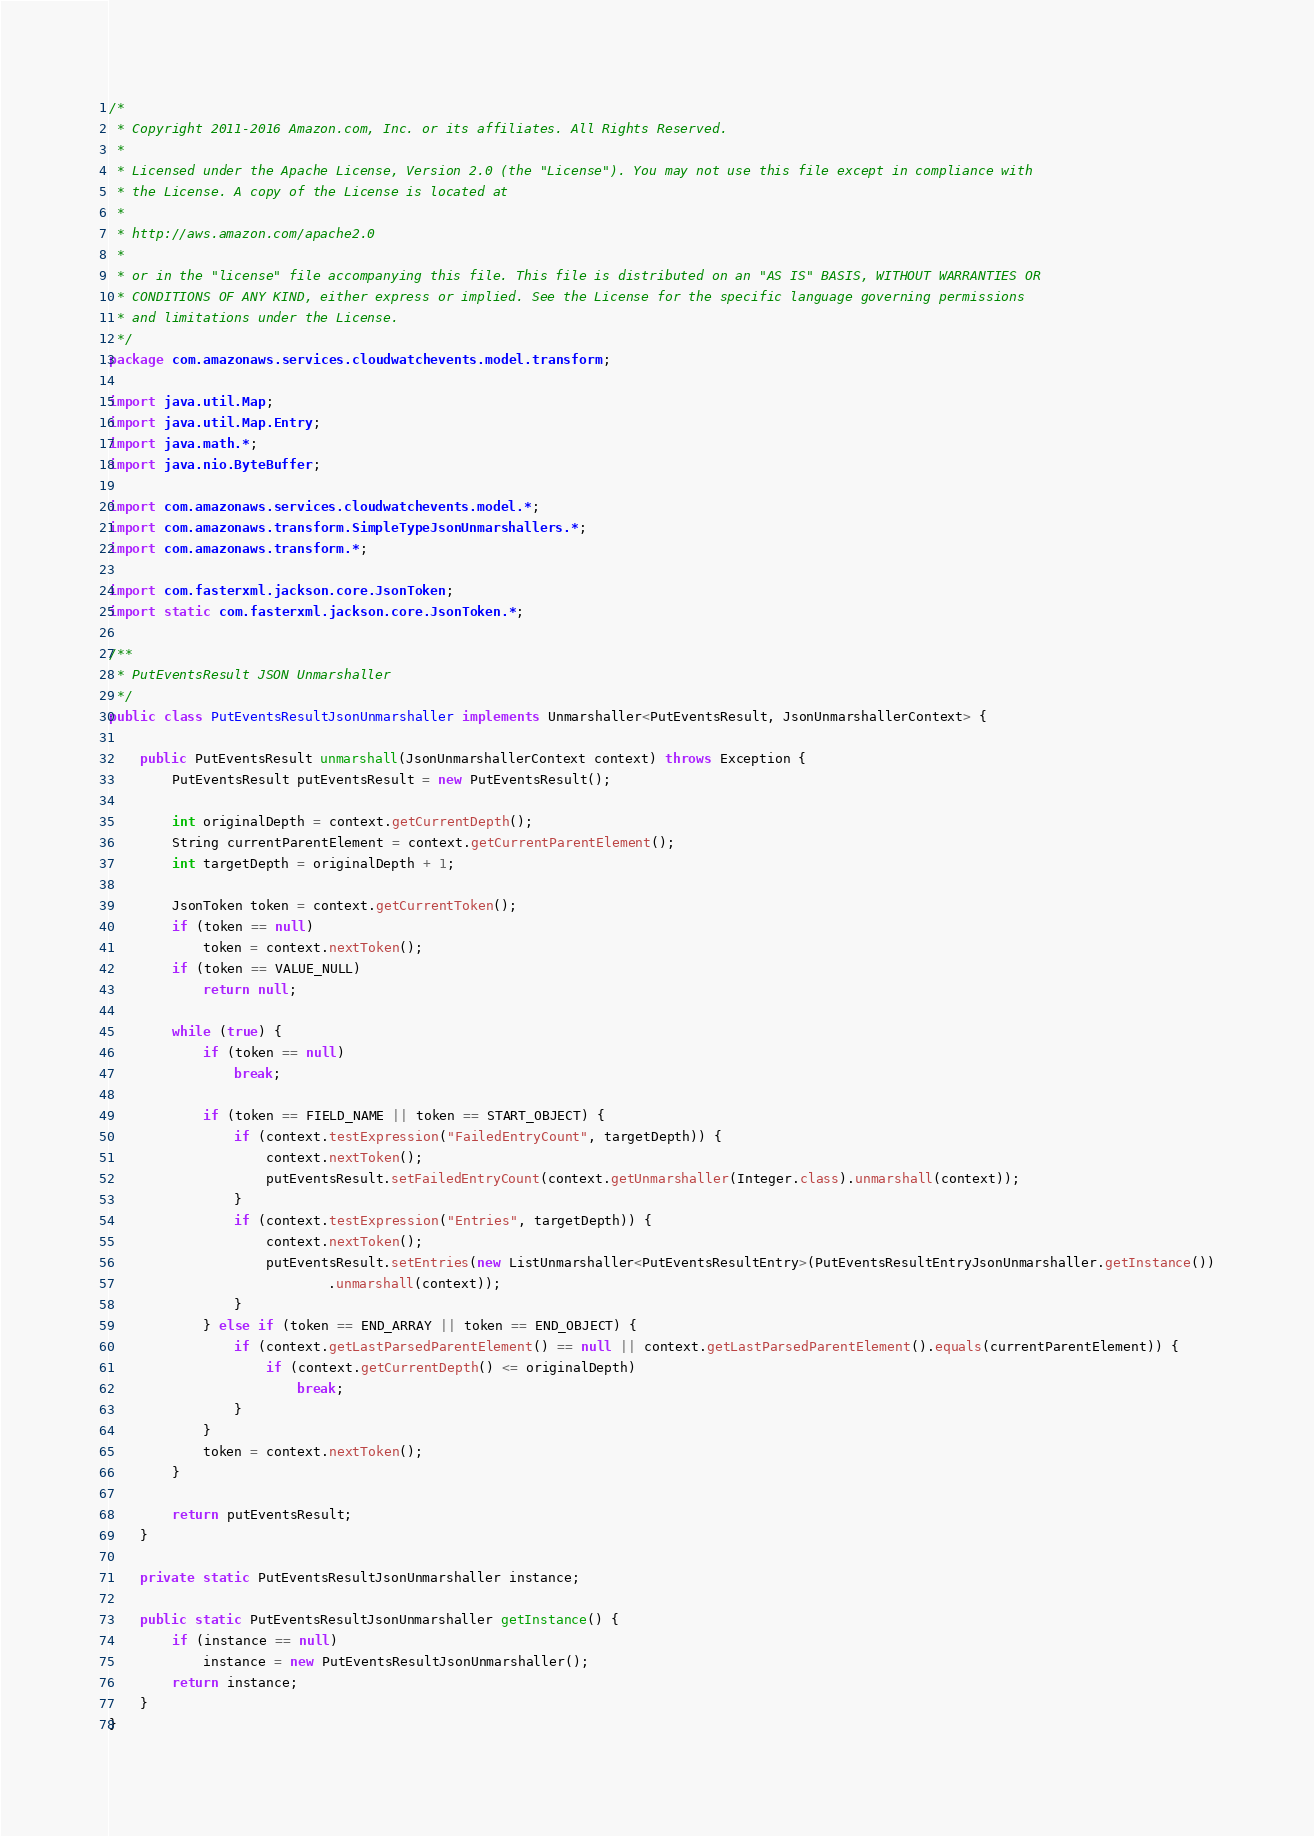Convert code to text. <code><loc_0><loc_0><loc_500><loc_500><_Java_>/*
 * Copyright 2011-2016 Amazon.com, Inc. or its affiliates. All Rights Reserved.
 * 
 * Licensed under the Apache License, Version 2.0 (the "License"). You may not use this file except in compliance with
 * the License. A copy of the License is located at
 * 
 * http://aws.amazon.com/apache2.0
 * 
 * or in the "license" file accompanying this file. This file is distributed on an "AS IS" BASIS, WITHOUT WARRANTIES OR
 * CONDITIONS OF ANY KIND, either express or implied. See the License for the specific language governing permissions
 * and limitations under the License.
 */
package com.amazonaws.services.cloudwatchevents.model.transform;

import java.util.Map;
import java.util.Map.Entry;
import java.math.*;
import java.nio.ByteBuffer;

import com.amazonaws.services.cloudwatchevents.model.*;
import com.amazonaws.transform.SimpleTypeJsonUnmarshallers.*;
import com.amazonaws.transform.*;

import com.fasterxml.jackson.core.JsonToken;
import static com.fasterxml.jackson.core.JsonToken.*;

/**
 * PutEventsResult JSON Unmarshaller
 */
public class PutEventsResultJsonUnmarshaller implements Unmarshaller<PutEventsResult, JsonUnmarshallerContext> {

    public PutEventsResult unmarshall(JsonUnmarshallerContext context) throws Exception {
        PutEventsResult putEventsResult = new PutEventsResult();

        int originalDepth = context.getCurrentDepth();
        String currentParentElement = context.getCurrentParentElement();
        int targetDepth = originalDepth + 1;

        JsonToken token = context.getCurrentToken();
        if (token == null)
            token = context.nextToken();
        if (token == VALUE_NULL)
            return null;

        while (true) {
            if (token == null)
                break;

            if (token == FIELD_NAME || token == START_OBJECT) {
                if (context.testExpression("FailedEntryCount", targetDepth)) {
                    context.nextToken();
                    putEventsResult.setFailedEntryCount(context.getUnmarshaller(Integer.class).unmarshall(context));
                }
                if (context.testExpression("Entries", targetDepth)) {
                    context.nextToken();
                    putEventsResult.setEntries(new ListUnmarshaller<PutEventsResultEntry>(PutEventsResultEntryJsonUnmarshaller.getInstance())
                            .unmarshall(context));
                }
            } else if (token == END_ARRAY || token == END_OBJECT) {
                if (context.getLastParsedParentElement() == null || context.getLastParsedParentElement().equals(currentParentElement)) {
                    if (context.getCurrentDepth() <= originalDepth)
                        break;
                }
            }
            token = context.nextToken();
        }

        return putEventsResult;
    }

    private static PutEventsResultJsonUnmarshaller instance;

    public static PutEventsResultJsonUnmarshaller getInstance() {
        if (instance == null)
            instance = new PutEventsResultJsonUnmarshaller();
        return instance;
    }
}
</code> 